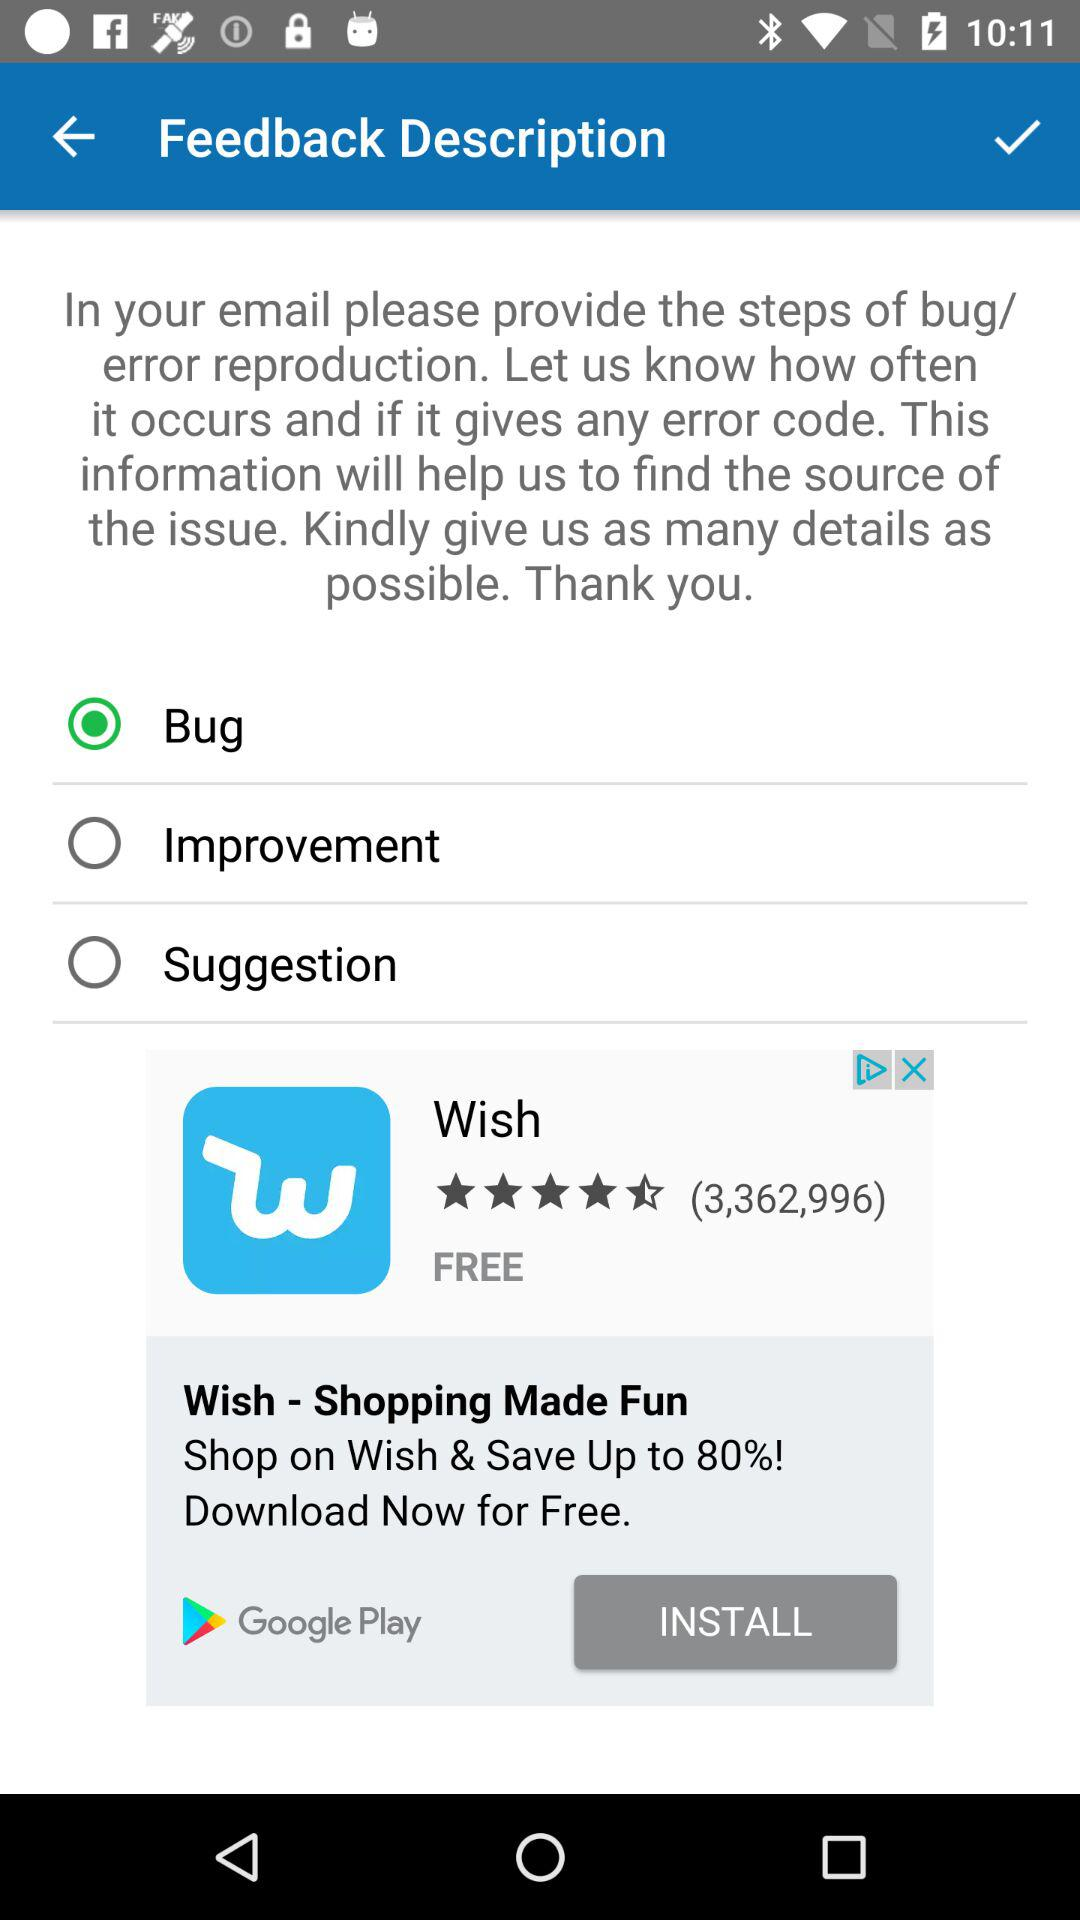Which option has been selected? The selected option is "Bug". 